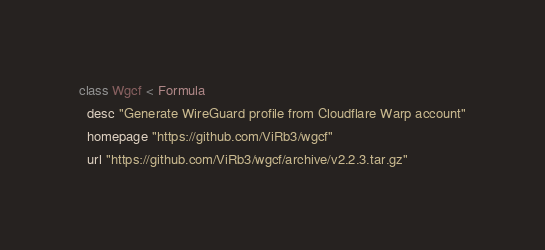<code> <loc_0><loc_0><loc_500><loc_500><_Ruby_>class Wgcf < Formula
  desc "Generate WireGuard profile from Cloudflare Warp account"
  homepage "https://github.com/ViRb3/wgcf"
  url "https://github.com/ViRb3/wgcf/archive/v2.2.3.tar.gz"</code> 